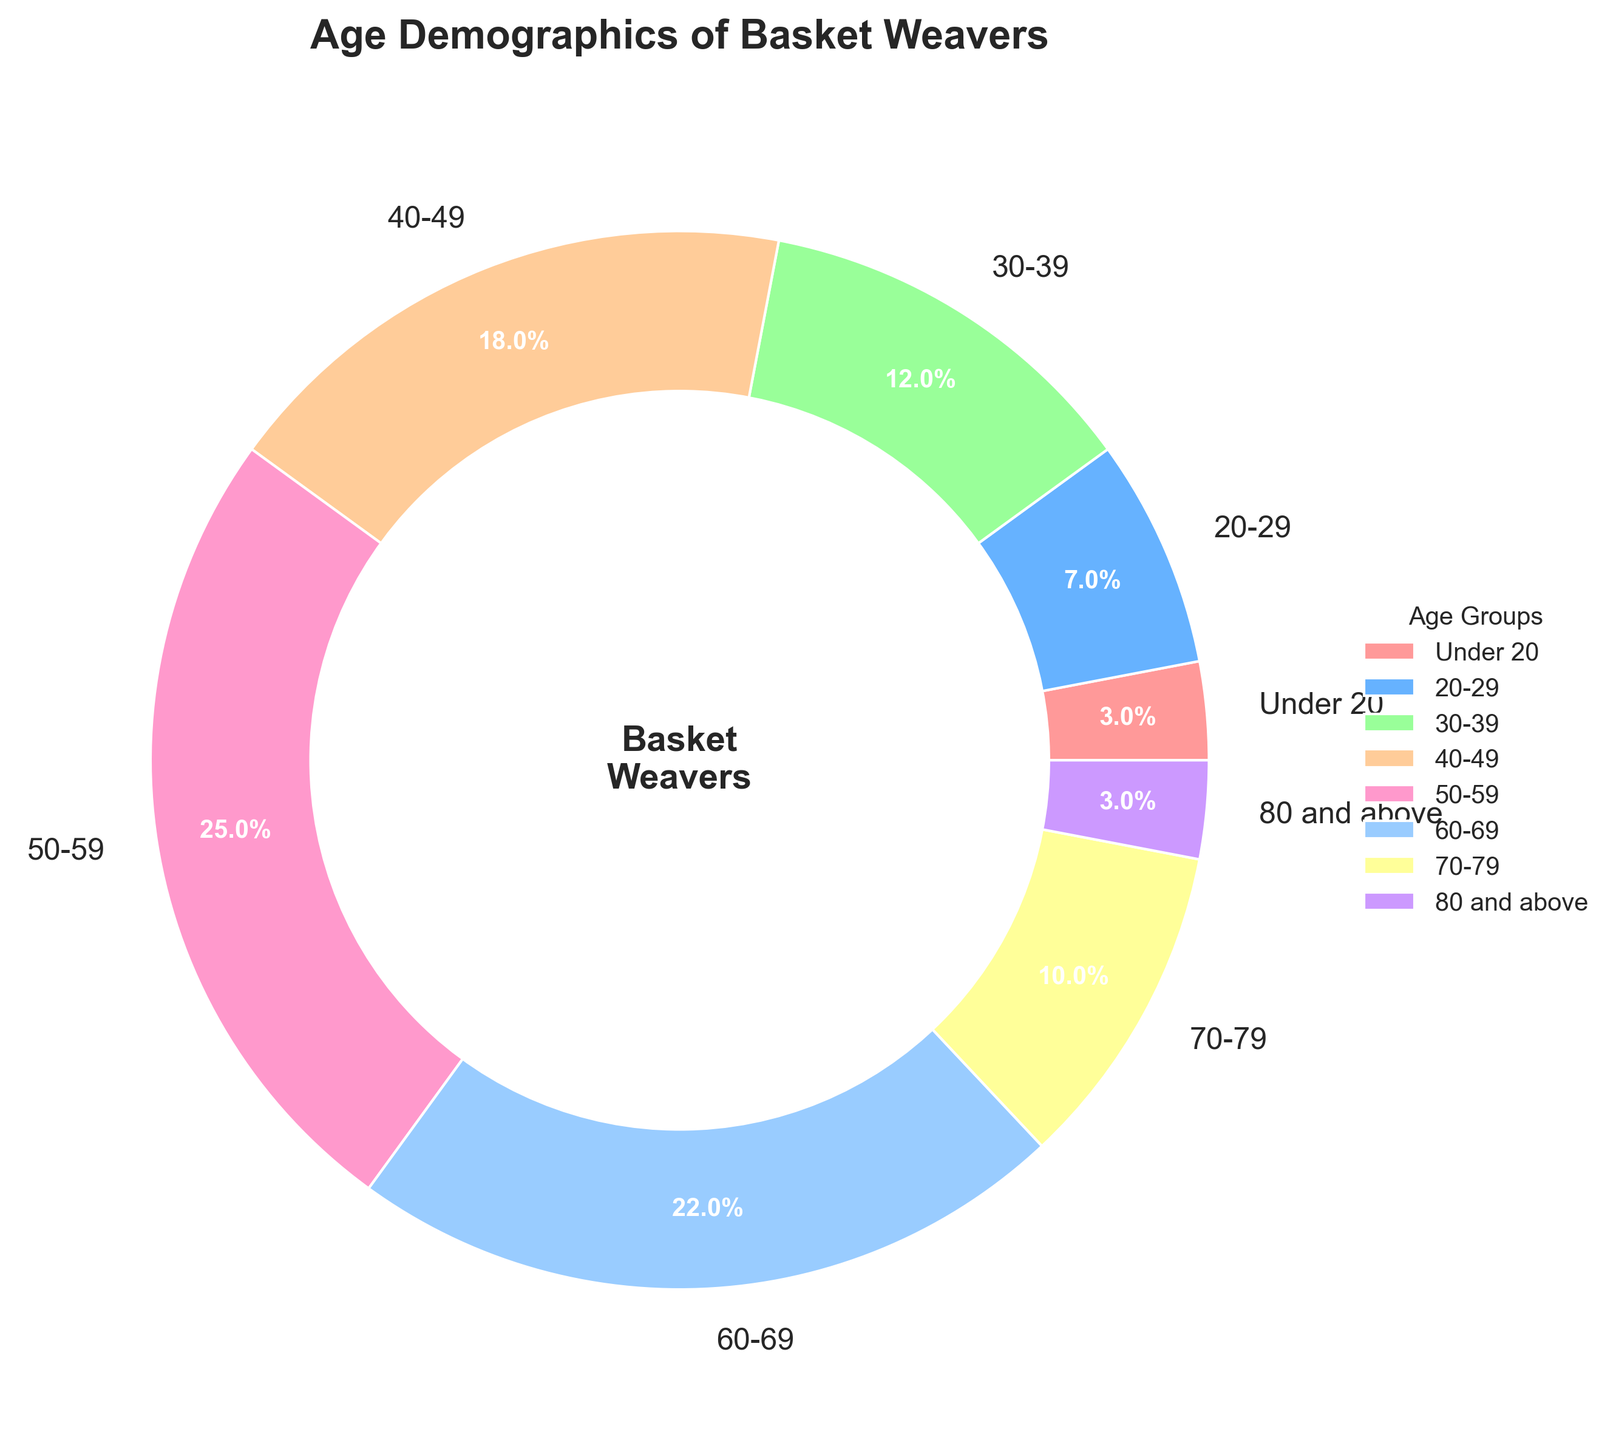What age group has the highest percentage of basket weavers? The figure shows a pie chart with different age groups marked. The largest segment belongs to the 50-59 age group at 25%.
Answer: 50-59 What is the combined percentage of basket weavers who are 60 and older? Combine the percentage of the 60-69, 70-79, and 80 and above age groups: 22% + 10% + 3% = 35%.
Answer: 35% Which age group has fewer basket weavers: 20-29 or 70-79? According to the pie chart, the 20-29 age group has 7% and the 70-79 age group has 10%. Therefore, 20-29 has fewer basket weavers.
Answer: 20-29 What's the difference between the percentage of basket weavers aged 40-49 and those aged 60-69? Subtract the percentage of the 60-69 age group from the 40-49 age group: 18% - 22% = -4%.
Answer: -4% Which age group is represented by the segment colored in light pink? The figure's legend indicates that the light pink segment corresponds to the Under 20 age group, which comprises 3%.
Answer: Under 20 How many age groups make up more than 20% of the basket weaver population? Review the pie chart and count the age groups with more than 20%. The 50-59 (25%) and 60-69 (22%) groups each exceed this threshold.
Answer: 2 Are there age groups that have an equal percentage of the basket weaver population? The fig shows that both the Under 20 and 80 and above age groups have 3%, making them equal in percentage.
Answer: Yes What is the average percentage of basket weavers for those aged under 50? Calculate the sum of percentages for the Under 20, 20-29, 30-39, and 40-49 age groups and divide by 4: (3% + 7% + 12% + 18%) / 4 = 10%.
Answer: 10% Which age group has the smallest wedge in the pie chart, and what is their percentage? The figure shows that the Under 20 and 80 and above age groups have the smallest wedge, each with a percentage of 3%.
Answer: Under 20, 3% How does the percentage of basket weavers aged 30-39 compare to those aged 40-49? The chart indicates that the 30-39 age group is 12%, while the 40-49 age group is 18%. Hence, the 30-39 age group is smaller by 6%.
Answer: Smaller by 6% 